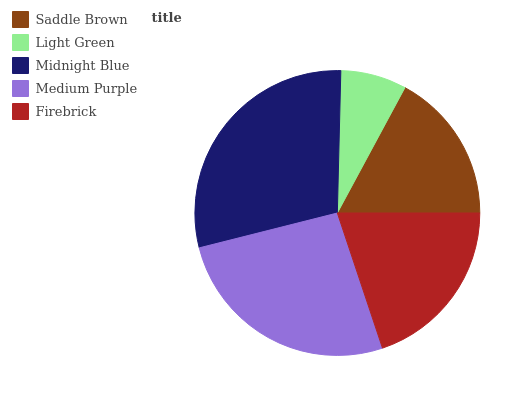Is Light Green the minimum?
Answer yes or no. Yes. Is Midnight Blue the maximum?
Answer yes or no. Yes. Is Midnight Blue the minimum?
Answer yes or no. No. Is Light Green the maximum?
Answer yes or no. No. Is Midnight Blue greater than Light Green?
Answer yes or no. Yes. Is Light Green less than Midnight Blue?
Answer yes or no. Yes. Is Light Green greater than Midnight Blue?
Answer yes or no. No. Is Midnight Blue less than Light Green?
Answer yes or no. No. Is Firebrick the high median?
Answer yes or no. Yes. Is Firebrick the low median?
Answer yes or no. Yes. Is Saddle Brown the high median?
Answer yes or no. No. Is Saddle Brown the low median?
Answer yes or no. No. 